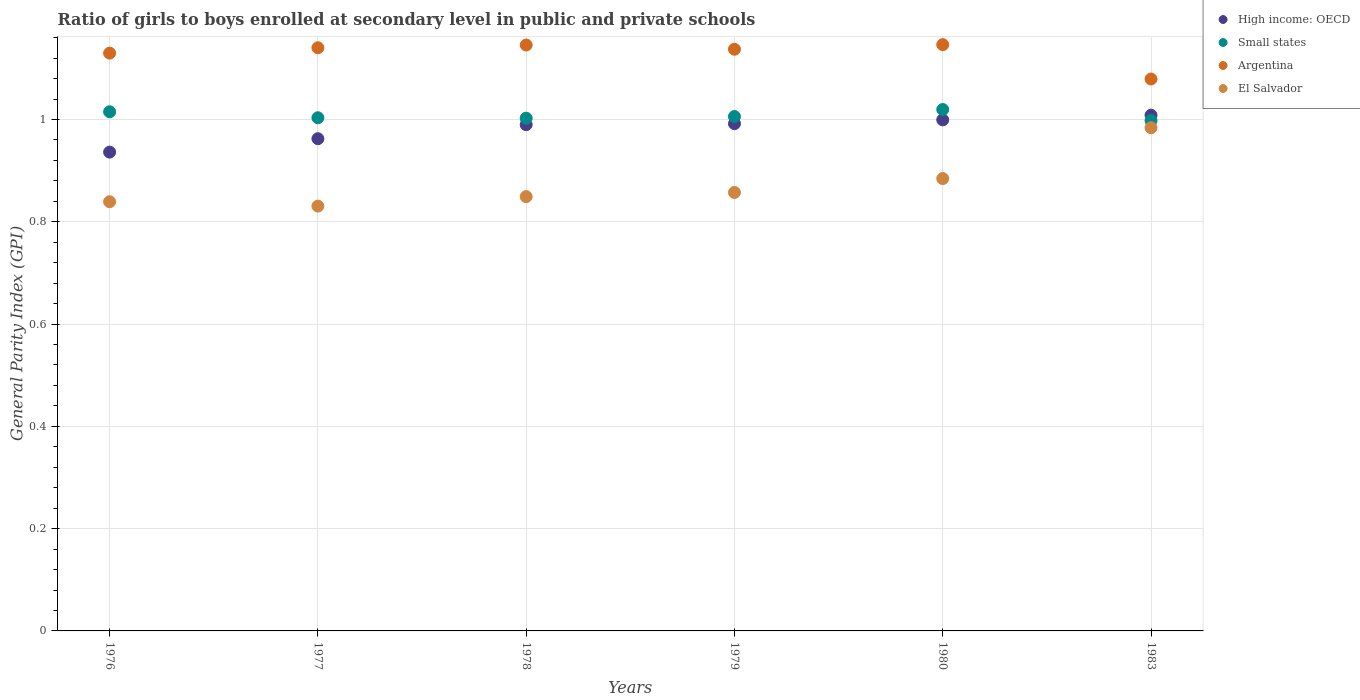Is the number of dotlines equal to the number of legend labels?
Make the answer very short. Yes. What is the general parity index in High income: OECD in 1979?
Provide a short and direct response. 0.99. Across all years, what is the maximum general parity index in El Salvador?
Ensure brevity in your answer.  0.98. Across all years, what is the minimum general parity index in High income: OECD?
Provide a succinct answer. 0.94. What is the total general parity index in Small states in the graph?
Your response must be concise. 6.04. What is the difference between the general parity index in Small states in 1977 and that in 1978?
Make the answer very short. 0. What is the difference between the general parity index in El Salvador in 1976 and the general parity index in High income: OECD in 1977?
Your response must be concise. -0.12. What is the average general parity index in El Salvador per year?
Keep it short and to the point. 0.87. In the year 1977, what is the difference between the general parity index in Argentina and general parity index in Small states?
Provide a succinct answer. 0.14. In how many years, is the general parity index in High income: OECD greater than 0.12?
Your answer should be very brief. 6. What is the ratio of the general parity index in Small states in 1976 to that in 1977?
Provide a short and direct response. 1.01. Is the general parity index in High income: OECD in 1980 less than that in 1983?
Offer a very short reply. Yes. What is the difference between the highest and the second highest general parity index in High income: OECD?
Give a very brief answer. 0.01. What is the difference between the highest and the lowest general parity index in Argentina?
Give a very brief answer. 0.07. In how many years, is the general parity index in Small states greater than the average general parity index in Small states taken over all years?
Make the answer very short. 2. Is the sum of the general parity index in High income: OECD in 1976 and 1983 greater than the maximum general parity index in Argentina across all years?
Offer a terse response. Yes. Is it the case that in every year, the sum of the general parity index in Small states and general parity index in El Salvador  is greater than the sum of general parity index in Argentina and general parity index in High income: OECD?
Provide a short and direct response. No. Is it the case that in every year, the sum of the general parity index in High income: OECD and general parity index in Small states  is greater than the general parity index in Argentina?
Your answer should be very brief. Yes. Does the general parity index in Argentina monotonically increase over the years?
Keep it short and to the point. No. How many dotlines are there?
Keep it short and to the point. 4. How many years are there in the graph?
Your answer should be compact. 6. Are the values on the major ticks of Y-axis written in scientific E-notation?
Ensure brevity in your answer.  No. Does the graph contain any zero values?
Keep it short and to the point. No. Does the graph contain grids?
Provide a succinct answer. Yes. Where does the legend appear in the graph?
Your answer should be very brief. Top right. How are the legend labels stacked?
Offer a very short reply. Vertical. What is the title of the graph?
Provide a short and direct response. Ratio of girls to boys enrolled at secondary level in public and private schools. Does "Euro area" appear as one of the legend labels in the graph?
Your answer should be compact. No. What is the label or title of the Y-axis?
Give a very brief answer. General Parity Index (GPI). What is the General Parity Index (GPI) in High income: OECD in 1976?
Your answer should be compact. 0.94. What is the General Parity Index (GPI) in Small states in 1976?
Provide a short and direct response. 1.02. What is the General Parity Index (GPI) in Argentina in 1976?
Your answer should be very brief. 1.13. What is the General Parity Index (GPI) in El Salvador in 1976?
Provide a succinct answer. 0.84. What is the General Parity Index (GPI) of High income: OECD in 1977?
Ensure brevity in your answer.  0.96. What is the General Parity Index (GPI) in Small states in 1977?
Your answer should be very brief. 1. What is the General Parity Index (GPI) of Argentina in 1977?
Offer a terse response. 1.14. What is the General Parity Index (GPI) of El Salvador in 1977?
Offer a very short reply. 0.83. What is the General Parity Index (GPI) of High income: OECD in 1978?
Provide a short and direct response. 0.99. What is the General Parity Index (GPI) in Small states in 1978?
Provide a succinct answer. 1. What is the General Parity Index (GPI) in Argentina in 1978?
Keep it short and to the point. 1.15. What is the General Parity Index (GPI) of El Salvador in 1978?
Keep it short and to the point. 0.85. What is the General Parity Index (GPI) of High income: OECD in 1979?
Provide a short and direct response. 0.99. What is the General Parity Index (GPI) in Small states in 1979?
Your answer should be compact. 1.01. What is the General Parity Index (GPI) of Argentina in 1979?
Your answer should be very brief. 1.14. What is the General Parity Index (GPI) in El Salvador in 1979?
Offer a terse response. 0.86. What is the General Parity Index (GPI) of High income: OECD in 1980?
Offer a terse response. 1. What is the General Parity Index (GPI) in Small states in 1980?
Provide a short and direct response. 1.02. What is the General Parity Index (GPI) in Argentina in 1980?
Ensure brevity in your answer.  1.15. What is the General Parity Index (GPI) in El Salvador in 1980?
Provide a succinct answer. 0.88. What is the General Parity Index (GPI) in High income: OECD in 1983?
Ensure brevity in your answer.  1.01. What is the General Parity Index (GPI) of Small states in 1983?
Offer a terse response. 1. What is the General Parity Index (GPI) of Argentina in 1983?
Your answer should be very brief. 1.08. What is the General Parity Index (GPI) of El Salvador in 1983?
Ensure brevity in your answer.  0.98. Across all years, what is the maximum General Parity Index (GPI) of High income: OECD?
Your answer should be very brief. 1.01. Across all years, what is the maximum General Parity Index (GPI) in Small states?
Ensure brevity in your answer.  1.02. Across all years, what is the maximum General Parity Index (GPI) of Argentina?
Offer a terse response. 1.15. Across all years, what is the maximum General Parity Index (GPI) of El Salvador?
Keep it short and to the point. 0.98. Across all years, what is the minimum General Parity Index (GPI) of High income: OECD?
Your response must be concise. 0.94. Across all years, what is the minimum General Parity Index (GPI) in Small states?
Ensure brevity in your answer.  1. Across all years, what is the minimum General Parity Index (GPI) in Argentina?
Offer a terse response. 1.08. Across all years, what is the minimum General Parity Index (GPI) of El Salvador?
Make the answer very short. 0.83. What is the total General Parity Index (GPI) in High income: OECD in the graph?
Your answer should be compact. 5.89. What is the total General Parity Index (GPI) of Small states in the graph?
Give a very brief answer. 6.04. What is the total General Parity Index (GPI) of Argentina in the graph?
Offer a very short reply. 6.78. What is the total General Parity Index (GPI) in El Salvador in the graph?
Keep it short and to the point. 5.24. What is the difference between the General Parity Index (GPI) in High income: OECD in 1976 and that in 1977?
Offer a terse response. -0.03. What is the difference between the General Parity Index (GPI) in Small states in 1976 and that in 1977?
Offer a very short reply. 0.01. What is the difference between the General Parity Index (GPI) in Argentina in 1976 and that in 1977?
Provide a succinct answer. -0.01. What is the difference between the General Parity Index (GPI) of El Salvador in 1976 and that in 1977?
Keep it short and to the point. 0.01. What is the difference between the General Parity Index (GPI) in High income: OECD in 1976 and that in 1978?
Keep it short and to the point. -0.05. What is the difference between the General Parity Index (GPI) of Small states in 1976 and that in 1978?
Give a very brief answer. 0.01. What is the difference between the General Parity Index (GPI) of Argentina in 1976 and that in 1978?
Make the answer very short. -0.02. What is the difference between the General Parity Index (GPI) of El Salvador in 1976 and that in 1978?
Your answer should be compact. -0.01. What is the difference between the General Parity Index (GPI) of High income: OECD in 1976 and that in 1979?
Offer a terse response. -0.06. What is the difference between the General Parity Index (GPI) of Small states in 1976 and that in 1979?
Offer a very short reply. 0.01. What is the difference between the General Parity Index (GPI) of Argentina in 1976 and that in 1979?
Your response must be concise. -0.01. What is the difference between the General Parity Index (GPI) of El Salvador in 1976 and that in 1979?
Offer a very short reply. -0.02. What is the difference between the General Parity Index (GPI) in High income: OECD in 1976 and that in 1980?
Your response must be concise. -0.06. What is the difference between the General Parity Index (GPI) of Small states in 1976 and that in 1980?
Offer a terse response. -0. What is the difference between the General Parity Index (GPI) of Argentina in 1976 and that in 1980?
Offer a terse response. -0.02. What is the difference between the General Parity Index (GPI) of El Salvador in 1976 and that in 1980?
Your response must be concise. -0.05. What is the difference between the General Parity Index (GPI) in High income: OECD in 1976 and that in 1983?
Offer a very short reply. -0.07. What is the difference between the General Parity Index (GPI) of Small states in 1976 and that in 1983?
Your answer should be compact. 0.02. What is the difference between the General Parity Index (GPI) in Argentina in 1976 and that in 1983?
Offer a terse response. 0.05. What is the difference between the General Parity Index (GPI) in El Salvador in 1976 and that in 1983?
Provide a short and direct response. -0.14. What is the difference between the General Parity Index (GPI) in High income: OECD in 1977 and that in 1978?
Keep it short and to the point. -0.03. What is the difference between the General Parity Index (GPI) of Small states in 1977 and that in 1978?
Ensure brevity in your answer.  0. What is the difference between the General Parity Index (GPI) in Argentina in 1977 and that in 1978?
Provide a short and direct response. -0.01. What is the difference between the General Parity Index (GPI) in El Salvador in 1977 and that in 1978?
Keep it short and to the point. -0.02. What is the difference between the General Parity Index (GPI) of High income: OECD in 1977 and that in 1979?
Make the answer very short. -0.03. What is the difference between the General Parity Index (GPI) of Small states in 1977 and that in 1979?
Provide a short and direct response. -0. What is the difference between the General Parity Index (GPI) in Argentina in 1977 and that in 1979?
Offer a very short reply. 0. What is the difference between the General Parity Index (GPI) in El Salvador in 1977 and that in 1979?
Give a very brief answer. -0.03. What is the difference between the General Parity Index (GPI) of High income: OECD in 1977 and that in 1980?
Offer a very short reply. -0.04. What is the difference between the General Parity Index (GPI) in Small states in 1977 and that in 1980?
Your answer should be compact. -0.02. What is the difference between the General Parity Index (GPI) of Argentina in 1977 and that in 1980?
Provide a succinct answer. -0.01. What is the difference between the General Parity Index (GPI) in El Salvador in 1977 and that in 1980?
Keep it short and to the point. -0.05. What is the difference between the General Parity Index (GPI) in High income: OECD in 1977 and that in 1983?
Keep it short and to the point. -0.05. What is the difference between the General Parity Index (GPI) of Small states in 1977 and that in 1983?
Give a very brief answer. 0.01. What is the difference between the General Parity Index (GPI) in Argentina in 1977 and that in 1983?
Offer a terse response. 0.06. What is the difference between the General Parity Index (GPI) in El Salvador in 1977 and that in 1983?
Offer a terse response. -0.15. What is the difference between the General Parity Index (GPI) in High income: OECD in 1978 and that in 1979?
Make the answer very short. -0. What is the difference between the General Parity Index (GPI) in Small states in 1978 and that in 1979?
Make the answer very short. -0. What is the difference between the General Parity Index (GPI) in Argentina in 1978 and that in 1979?
Offer a terse response. 0.01. What is the difference between the General Parity Index (GPI) of El Salvador in 1978 and that in 1979?
Give a very brief answer. -0.01. What is the difference between the General Parity Index (GPI) of High income: OECD in 1978 and that in 1980?
Your answer should be very brief. -0.01. What is the difference between the General Parity Index (GPI) of Small states in 1978 and that in 1980?
Give a very brief answer. -0.02. What is the difference between the General Parity Index (GPI) in Argentina in 1978 and that in 1980?
Your response must be concise. -0. What is the difference between the General Parity Index (GPI) in El Salvador in 1978 and that in 1980?
Ensure brevity in your answer.  -0.04. What is the difference between the General Parity Index (GPI) of High income: OECD in 1978 and that in 1983?
Your answer should be compact. -0.02. What is the difference between the General Parity Index (GPI) of Small states in 1978 and that in 1983?
Ensure brevity in your answer.  0. What is the difference between the General Parity Index (GPI) of Argentina in 1978 and that in 1983?
Your answer should be compact. 0.07. What is the difference between the General Parity Index (GPI) in El Salvador in 1978 and that in 1983?
Your response must be concise. -0.13. What is the difference between the General Parity Index (GPI) of High income: OECD in 1979 and that in 1980?
Offer a very short reply. -0.01. What is the difference between the General Parity Index (GPI) in Small states in 1979 and that in 1980?
Your response must be concise. -0.01. What is the difference between the General Parity Index (GPI) of Argentina in 1979 and that in 1980?
Your response must be concise. -0.01. What is the difference between the General Parity Index (GPI) of El Salvador in 1979 and that in 1980?
Give a very brief answer. -0.03. What is the difference between the General Parity Index (GPI) of High income: OECD in 1979 and that in 1983?
Keep it short and to the point. -0.02. What is the difference between the General Parity Index (GPI) of Small states in 1979 and that in 1983?
Give a very brief answer. 0.01. What is the difference between the General Parity Index (GPI) of Argentina in 1979 and that in 1983?
Ensure brevity in your answer.  0.06. What is the difference between the General Parity Index (GPI) of El Salvador in 1979 and that in 1983?
Provide a succinct answer. -0.13. What is the difference between the General Parity Index (GPI) of High income: OECD in 1980 and that in 1983?
Your answer should be compact. -0.01. What is the difference between the General Parity Index (GPI) in Small states in 1980 and that in 1983?
Provide a succinct answer. 0.02. What is the difference between the General Parity Index (GPI) of Argentina in 1980 and that in 1983?
Give a very brief answer. 0.07. What is the difference between the General Parity Index (GPI) in El Salvador in 1980 and that in 1983?
Provide a succinct answer. -0.1. What is the difference between the General Parity Index (GPI) in High income: OECD in 1976 and the General Parity Index (GPI) in Small states in 1977?
Keep it short and to the point. -0.07. What is the difference between the General Parity Index (GPI) of High income: OECD in 1976 and the General Parity Index (GPI) of Argentina in 1977?
Offer a terse response. -0.2. What is the difference between the General Parity Index (GPI) in High income: OECD in 1976 and the General Parity Index (GPI) in El Salvador in 1977?
Offer a very short reply. 0.11. What is the difference between the General Parity Index (GPI) in Small states in 1976 and the General Parity Index (GPI) in Argentina in 1977?
Ensure brevity in your answer.  -0.13. What is the difference between the General Parity Index (GPI) in Small states in 1976 and the General Parity Index (GPI) in El Salvador in 1977?
Make the answer very short. 0.18. What is the difference between the General Parity Index (GPI) in Argentina in 1976 and the General Parity Index (GPI) in El Salvador in 1977?
Provide a succinct answer. 0.3. What is the difference between the General Parity Index (GPI) in High income: OECD in 1976 and the General Parity Index (GPI) in Small states in 1978?
Keep it short and to the point. -0.07. What is the difference between the General Parity Index (GPI) in High income: OECD in 1976 and the General Parity Index (GPI) in Argentina in 1978?
Keep it short and to the point. -0.21. What is the difference between the General Parity Index (GPI) of High income: OECD in 1976 and the General Parity Index (GPI) of El Salvador in 1978?
Keep it short and to the point. 0.09. What is the difference between the General Parity Index (GPI) in Small states in 1976 and the General Parity Index (GPI) in Argentina in 1978?
Provide a short and direct response. -0.13. What is the difference between the General Parity Index (GPI) of Small states in 1976 and the General Parity Index (GPI) of El Salvador in 1978?
Provide a succinct answer. 0.17. What is the difference between the General Parity Index (GPI) of Argentina in 1976 and the General Parity Index (GPI) of El Salvador in 1978?
Provide a short and direct response. 0.28. What is the difference between the General Parity Index (GPI) of High income: OECD in 1976 and the General Parity Index (GPI) of Small states in 1979?
Your answer should be compact. -0.07. What is the difference between the General Parity Index (GPI) of High income: OECD in 1976 and the General Parity Index (GPI) of Argentina in 1979?
Ensure brevity in your answer.  -0.2. What is the difference between the General Parity Index (GPI) of High income: OECD in 1976 and the General Parity Index (GPI) of El Salvador in 1979?
Provide a short and direct response. 0.08. What is the difference between the General Parity Index (GPI) in Small states in 1976 and the General Parity Index (GPI) in Argentina in 1979?
Make the answer very short. -0.12. What is the difference between the General Parity Index (GPI) in Small states in 1976 and the General Parity Index (GPI) in El Salvador in 1979?
Provide a short and direct response. 0.16. What is the difference between the General Parity Index (GPI) of Argentina in 1976 and the General Parity Index (GPI) of El Salvador in 1979?
Give a very brief answer. 0.27. What is the difference between the General Parity Index (GPI) of High income: OECD in 1976 and the General Parity Index (GPI) of Small states in 1980?
Offer a terse response. -0.08. What is the difference between the General Parity Index (GPI) in High income: OECD in 1976 and the General Parity Index (GPI) in Argentina in 1980?
Your response must be concise. -0.21. What is the difference between the General Parity Index (GPI) of High income: OECD in 1976 and the General Parity Index (GPI) of El Salvador in 1980?
Offer a terse response. 0.05. What is the difference between the General Parity Index (GPI) in Small states in 1976 and the General Parity Index (GPI) in Argentina in 1980?
Your answer should be compact. -0.13. What is the difference between the General Parity Index (GPI) of Small states in 1976 and the General Parity Index (GPI) of El Salvador in 1980?
Your answer should be compact. 0.13. What is the difference between the General Parity Index (GPI) of Argentina in 1976 and the General Parity Index (GPI) of El Salvador in 1980?
Keep it short and to the point. 0.25. What is the difference between the General Parity Index (GPI) of High income: OECD in 1976 and the General Parity Index (GPI) of Small states in 1983?
Offer a terse response. -0.06. What is the difference between the General Parity Index (GPI) of High income: OECD in 1976 and the General Parity Index (GPI) of Argentina in 1983?
Your answer should be compact. -0.14. What is the difference between the General Parity Index (GPI) of High income: OECD in 1976 and the General Parity Index (GPI) of El Salvador in 1983?
Provide a short and direct response. -0.05. What is the difference between the General Parity Index (GPI) in Small states in 1976 and the General Parity Index (GPI) in Argentina in 1983?
Provide a succinct answer. -0.06. What is the difference between the General Parity Index (GPI) of Small states in 1976 and the General Parity Index (GPI) of El Salvador in 1983?
Your answer should be compact. 0.03. What is the difference between the General Parity Index (GPI) of Argentina in 1976 and the General Parity Index (GPI) of El Salvador in 1983?
Give a very brief answer. 0.15. What is the difference between the General Parity Index (GPI) in High income: OECD in 1977 and the General Parity Index (GPI) in Small states in 1978?
Ensure brevity in your answer.  -0.04. What is the difference between the General Parity Index (GPI) of High income: OECD in 1977 and the General Parity Index (GPI) of Argentina in 1978?
Your response must be concise. -0.18. What is the difference between the General Parity Index (GPI) in High income: OECD in 1977 and the General Parity Index (GPI) in El Salvador in 1978?
Your answer should be very brief. 0.11. What is the difference between the General Parity Index (GPI) of Small states in 1977 and the General Parity Index (GPI) of Argentina in 1978?
Your answer should be very brief. -0.14. What is the difference between the General Parity Index (GPI) in Small states in 1977 and the General Parity Index (GPI) in El Salvador in 1978?
Ensure brevity in your answer.  0.15. What is the difference between the General Parity Index (GPI) of Argentina in 1977 and the General Parity Index (GPI) of El Salvador in 1978?
Make the answer very short. 0.29. What is the difference between the General Parity Index (GPI) of High income: OECD in 1977 and the General Parity Index (GPI) of Small states in 1979?
Provide a succinct answer. -0.04. What is the difference between the General Parity Index (GPI) in High income: OECD in 1977 and the General Parity Index (GPI) in Argentina in 1979?
Keep it short and to the point. -0.17. What is the difference between the General Parity Index (GPI) of High income: OECD in 1977 and the General Parity Index (GPI) of El Salvador in 1979?
Offer a very short reply. 0.11. What is the difference between the General Parity Index (GPI) in Small states in 1977 and the General Parity Index (GPI) in Argentina in 1979?
Offer a terse response. -0.13. What is the difference between the General Parity Index (GPI) of Small states in 1977 and the General Parity Index (GPI) of El Salvador in 1979?
Provide a succinct answer. 0.15. What is the difference between the General Parity Index (GPI) of Argentina in 1977 and the General Parity Index (GPI) of El Salvador in 1979?
Make the answer very short. 0.28. What is the difference between the General Parity Index (GPI) of High income: OECD in 1977 and the General Parity Index (GPI) of Small states in 1980?
Ensure brevity in your answer.  -0.06. What is the difference between the General Parity Index (GPI) in High income: OECD in 1977 and the General Parity Index (GPI) in Argentina in 1980?
Make the answer very short. -0.18. What is the difference between the General Parity Index (GPI) in High income: OECD in 1977 and the General Parity Index (GPI) in El Salvador in 1980?
Provide a short and direct response. 0.08. What is the difference between the General Parity Index (GPI) in Small states in 1977 and the General Parity Index (GPI) in Argentina in 1980?
Provide a succinct answer. -0.14. What is the difference between the General Parity Index (GPI) of Small states in 1977 and the General Parity Index (GPI) of El Salvador in 1980?
Your response must be concise. 0.12. What is the difference between the General Parity Index (GPI) of Argentina in 1977 and the General Parity Index (GPI) of El Salvador in 1980?
Your answer should be compact. 0.26. What is the difference between the General Parity Index (GPI) of High income: OECD in 1977 and the General Parity Index (GPI) of Small states in 1983?
Your answer should be compact. -0.04. What is the difference between the General Parity Index (GPI) of High income: OECD in 1977 and the General Parity Index (GPI) of Argentina in 1983?
Your answer should be compact. -0.12. What is the difference between the General Parity Index (GPI) of High income: OECD in 1977 and the General Parity Index (GPI) of El Salvador in 1983?
Offer a terse response. -0.02. What is the difference between the General Parity Index (GPI) of Small states in 1977 and the General Parity Index (GPI) of Argentina in 1983?
Offer a terse response. -0.08. What is the difference between the General Parity Index (GPI) in Small states in 1977 and the General Parity Index (GPI) in El Salvador in 1983?
Ensure brevity in your answer.  0.02. What is the difference between the General Parity Index (GPI) in Argentina in 1977 and the General Parity Index (GPI) in El Salvador in 1983?
Provide a short and direct response. 0.16. What is the difference between the General Parity Index (GPI) of High income: OECD in 1978 and the General Parity Index (GPI) of Small states in 1979?
Offer a very short reply. -0.02. What is the difference between the General Parity Index (GPI) in High income: OECD in 1978 and the General Parity Index (GPI) in Argentina in 1979?
Keep it short and to the point. -0.15. What is the difference between the General Parity Index (GPI) of High income: OECD in 1978 and the General Parity Index (GPI) of El Salvador in 1979?
Keep it short and to the point. 0.13. What is the difference between the General Parity Index (GPI) in Small states in 1978 and the General Parity Index (GPI) in Argentina in 1979?
Offer a very short reply. -0.13. What is the difference between the General Parity Index (GPI) of Small states in 1978 and the General Parity Index (GPI) of El Salvador in 1979?
Make the answer very short. 0.15. What is the difference between the General Parity Index (GPI) of Argentina in 1978 and the General Parity Index (GPI) of El Salvador in 1979?
Ensure brevity in your answer.  0.29. What is the difference between the General Parity Index (GPI) in High income: OECD in 1978 and the General Parity Index (GPI) in Small states in 1980?
Offer a terse response. -0.03. What is the difference between the General Parity Index (GPI) in High income: OECD in 1978 and the General Parity Index (GPI) in Argentina in 1980?
Give a very brief answer. -0.16. What is the difference between the General Parity Index (GPI) of High income: OECD in 1978 and the General Parity Index (GPI) of El Salvador in 1980?
Provide a short and direct response. 0.11. What is the difference between the General Parity Index (GPI) in Small states in 1978 and the General Parity Index (GPI) in Argentina in 1980?
Keep it short and to the point. -0.14. What is the difference between the General Parity Index (GPI) in Small states in 1978 and the General Parity Index (GPI) in El Salvador in 1980?
Provide a short and direct response. 0.12. What is the difference between the General Parity Index (GPI) of Argentina in 1978 and the General Parity Index (GPI) of El Salvador in 1980?
Provide a short and direct response. 0.26. What is the difference between the General Parity Index (GPI) of High income: OECD in 1978 and the General Parity Index (GPI) of Small states in 1983?
Provide a short and direct response. -0.01. What is the difference between the General Parity Index (GPI) of High income: OECD in 1978 and the General Parity Index (GPI) of Argentina in 1983?
Offer a terse response. -0.09. What is the difference between the General Parity Index (GPI) in High income: OECD in 1978 and the General Parity Index (GPI) in El Salvador in 1983?
Your response must be concise. 0.01. What is the difference between the General Parity Index (GPI) in Small states in 1978 and the General Parity Index (GPI) in Argentina in 1983?
Give a very brief answer. -0.08. What is the difference between the General Parity Index (GPI) of Small states in 1978 and the General Parity Index (GPI) of El Salvador in 1983?
Make the answer very short. 0.02. What is the difference between the General Parity Index (GPI) in Argentina in 1978 and the General Parity Index (GPI) in El Salvador in 1983?
Make the answer very short. 0.16. What is the difference between the General Parity Index (GPI) of High income: OECD in 1979 and the General Parity Index (GPI) of Small states in 1980?
Provide a succinct answer. -0.03. What is the difference between the General Parity Index (GPI) of High income: OECD in 1979 and the General Parity Index (GPI) of Argentina in 1980?
Offer a very short reply. -0.15. What is the difference between the General Parity Index (GPI) of High income: OECD in 1979 and the General Parity Index (GPI) of El Salvador in 1980?
Give a very brief answer. 0.11. What is the difference between the General Parity Index (GPI) of Small states in 1979 and the General Parity Index (GPI) of Argentina in 1980?
Provide a succinct answer. -0.14. What is the difference between the General Parity Index (GPI) of Small states in 1979 and the General Parity Index (GPI) of El Salvador in 1980?
Your answer should be compact. 0.12. What is the difference between the General Parity Index (GPI) of Argentina in 1979 and the General Parity Index (GPI) of El Salvador in 1980?
Give a very brief answer. 0.25. What is the difference between the General Parity Index (GPI) in High income: OECD in 1979 and the General Parity Index (GPI) in Small states in 1983?
Give a very brief answer. -0.01. What is the difference between the General Parity Index (GPI) of High income: OECD in 1979 and the General Parity Index (GPI) of Argentina in 1983?
Your answer should be very brief. -0.09. What is the difference between the General Parity Index (GPI) in High income: OECD in 1979 and the General Parity Index (GPI) in El Salvador in 1983?
Your answer should be very brief. 0.01. What is the difference between the General Parity Index (GPI) in Small states in 1979 and the General Parity Index (GPI) in Argentina in 1983?
Offer a terse response. -0.07. What is the difference between the General Parity Index (GPI) of Small states in 1979 and the General Parity Index (GPI) of El Salvador in 1983?
Your answer should be very brief. 0.02. What is the difference between the General Parity Index (GPI) in Argentina in 1979 and the General Parity Index (GPI) in El Salvador in 1983?
Your answer should be very brief. 0.15. What is the difference between the General Parity Index (GPI) of High income: OECD in 1980 and the General Parity Index (GPI) of Small states in 1983?
Give a very brief answer. 0. What is the difference between the General Parity Index (GPI) in High income: OECD in 1980 and the General Parity Index (GPI) in Argentina in 1983?
Offer a terse response. -0.08. What is the difference between the General Parity Index (GPI) of High income: OECD in 1980 and the General Parity Index (GPI) of El Salvador in 1983?
Make the answer very short. 0.02. What is the difference between the General Parity Index (GPI) of Small states in 1980 and the General Parity Index (GPI) of Argentina in 1983?
Your answer should be very brief. -0.06. What is the difference between the General Parity Index (GPI) of Small states in 1980 and the General Parity Index (GPI) of El Salvador in 1983?
Provide a short and direct response. 0.04. What is the difference between the General Parity Index (GPI) of Argentina in 1980 and the General Parity Index (GPI) of El Salvador in 1983?
Offer a terse response. 0.16. What is the average General Parity Index (GPI) in High income: OECD per year?
Offer a terse response. 0.98. What is the average General Parity Index (GPI) in Small states per year?
Your response must be concise. 1.01. What is the average General Parity Index (GPI) of Argentina per year?
Offer a very short reply. 1.13. What is the average General Parity Index (GPI) of El Salvador per year?
Provide a short and direct response. 0.87. In the year 1976, what is the difference between the General Parity Index (GPI) in High income: OECD and General Parity Index (GPI) in Small states?
Keep it short and to the point. -0.08. In the year 1976, what is the difference between the General Parity Index (GPI) of High income: OECD and General Parity Index (GPI) of Argentina?
Provide a succinct answer. -0.19. In the year 1976, what is the difference between the General Parity Index (GPI) in High income: OECD and General Parity Index (GPI) in El Salvador?
Your answer should be compact. 0.1. In the year 1976, what is the difference between the General Parity Index (GPI) in Small states and General Parity Index (GPI) in Argentina?
Provide a short and direct response. -0.11. In the year 1976, what is the difference between the General Parity Index (GPI) in Small states and General Parity Index (GPI) in El Salvador?
Give a very brief answer. 0.18. In the year 1976, what is the difference between the General Parity Index (GPI) of Argentina and General Parity Index (GPI) of El Salvador?
Your answer should be compact. 0.29. In the year 1977, what is the difference between the General Parity Index (GPI) of High income: OECD and General Parity Index (GPI) of Small states?
Keep it short and to the point. -0.04. In the year 1977, what is the difference between the General Parity Index (GPI) of High income: OECD and General Parity Index (GPI) of Argentina?
Your answer should be very brief. -0.18. In the year 1977, what is the difference between the General Parity Index (GPI) in High income: OECD and General Parity Index (GPI) in El Salvador?
Provide a short and direct response. 0.13. In the year 1977, what is the difference between the General Parity Index (GPI) in Small states and General Parity Index (GPI) in Argentina?
Your answer should be compact. -0.14. In the year 1977, what is the difference between the General Parity Index (GPI) of Small states and General Parity Index (GPI) of El Salvador?
Your answer should be compact. 0.17. In the year 1977, what is the difference between the General Parity Index (GPI) in Argentina and General Parity Index (GPI) in El Salvador?
Provide a succinct answer. 0.31. In the year 1978, what is the difference between the General Parity Index (GPI) of High income: OECD and General Parity Index (GPI) of Small states?
Offer a terse response. -0.01. In the year 1978, what is the difference between the General Parity Index (GPI) in High income: OECD and General Parity Index (GPI) in Argentina?
Provide a short and direct response. -0.16. In the year 1978, what is the difference between the General Parity Index (GPI) in High income: OECD and General Parity Index (GPI) in El Salvador?
Offer a very short reply. 0.14. In the year 1978, what is the difference between the General Parity Index (GPI) in Small states and General Parity Index (GPI) in Argentina?
Provide a succinct answer. -0.14. In the year 1978, what is the difference between the General Parity Index (GPI) of Small states and General Parity Index (GPI) of El Salvador?
Keep it short and to the point. 0.15. In the year 1978, what is the difference between the General Parity Index (GPI) in Argentina and General Parity Index (GPI) in El Salvador?
Give a very brief answer. 0.3. In the year 1979, what is the difference between the General Parity Index (GPI) in High income: OECD and General Parity Index (GPI) in Small states?
Provide a succinct answer. -0.01. In the year 1979, what is the difference between the General Parity Index (GPI) of High income: OECD and General Parity Index (GPI) of Argentina?
Offer a terse response. -0.15. In the year 1979, what is the difference between the General Parity Index (GPI) of High income: OECD and General Parity Index (GPI) of El Salvador?
Give a very brief answer. 0.13. In the year 1979, what is the difference between the General Parity Index (GPI) of Small states and General Parity Index (GPI) of Argentina?
Your response must be concise. -0.13. In the year 1979, what is the difference between the General Parity Index (GPI) in Small states and General Parity Index (GPI) in El Salvador?
Provide a succinct answer. 0.15. In the year 1979, what is the difference between the General Parity Index (GPI) in Argentina and General Parity Index (GPI) in El Salvador?
Your response must be concise. 0.28. In the year 1980, what is the difference between the General Parity Index (GPI) of High income: OECD and General Parity Index (GPI) of Small states?
Give a very brief answer. -0.02. In the year 1980, what is the difference between the General Parity Index (GPI) in High income: OECD and General Parity Index (GPI) in Argentina?
Your answer should be compact. -0.15. In the year 1980, what is the difference between the General Parity Index (GPI) in High income: OECD and General Parity Index (GPI) in El Salvador?
Your answer should be compact. 0.11. In the year 1980, what is the difference between the General Parity Index (GPI) of Small states and General Parity Index (GPI) of Argentina?
Give a very brief answer. -0.13. In the year 1980, what is the difference between the General Parity Index (GPI) in Small states and General Parity Index (GPI) in El Salvador?
Offer a very short reply. 0.14. In the year 1980, what is the difference between the General Parity Index (GPI) of Argentina and General Parity Index (GPI) of El Salvador?
Make the answer very short. 0.26. In the year 1983, what is the difference between the General Parity Index (GPI) of High income: OECD and General Parity Index (GPI) of Small states?
Give a very brief answer. 0.01. In the year 1983, what is the difference between the General Parity Index (GPI) in High income: OECD and General Parity Index (GPI) in Argentina?
Keep it short and to the point. -0.07. In the year 1983, what is the difference between the General Parity Index (GPI) in High income: OECD and General Parity Index (GPI) in El Salvador?
Offer a terse response. 0.02. In the year 1983, what is the difference between the General Parity Index (GPI) in Small states and General Parity Index (GPI) in Argentina?
Provide a short and direct response. -0.08. In the year 1983, what is the difference between the General Parity Index (GPI) of Small states and General Parity Index (GPI) of El Salvador?
Provide a short and direct response. 0.01. In the year 1983, what is the difference between the General Parity Index (GPI) of Argentina and General Parity Index (GPI) of El Salvador?
Provide a short and direct response. 0.1. What is the ratio of the General Parity Index (GPI) of High income: OECD in 1976 to that in 1977?
Your answer should be compact. 0.97. What is the ratio of the General Parity Index (GPI) in Small states in 1976 to that in 1977?
Ensure brevity in your answer.  1.01. What is the ratio of the General Parity Index (GPI) of El Salvador in 1976 to that in 1977?
Provide a succinct answer. 1.01. What is the ratio of the General Parity Index (GPI) of High income: OECD in 1976 to that in 1978?
Offer a terse response. 0.95. What is the ratio of the General Parity Index (GPI) of Small states in 1976 to that in 1978?
Offer a terse response. 1.01. What is the ratio of the General Parity Index (GPI) in Argentina in 1976 to that in 1978?
Give a very brief answer. 0.99. What is the ratio of the General Parity Index (GPI) in El Salvador in 1976 to that in 1978?
Give a very brief answer. 0.99. What is the ratio of the General Parity Index (GPI) of High income: OECD in 1976 to that in 1979?
Your answer should be compact. 0.94. What is the ratio of the General Parity Index (GPI) of Small states in 1976 to that in 1979?
Provide a short and direct response. 1.01. What is the ratio of the General Parity Index (GPI) in El Salvador in 1976 to that in 1979?
Ensure brevity in your answer.  0.98. What is the ratio of the General Parity Index (GPI) of High income: OECD in 1976 to that in 1980?
Provide a succinct answer. 0.94. What is the ratio of the General Parity Index (GPI) in Small states in 1976 to that in 1980?
Your response must be concise. 1. What is the ratio of the General Parity Index (GPI) of Argentina in 1976 to that in 1980?
Your answer should be compact. 0.99. What is the ratio of the General Parity Index (GPI) of El Salvador in 1976 to that in 1980?
Give a very brief answer. 0.95. What is the ratio of the General Parity Index (GPI) of High income: OECD in 1976 to that in 1983?
Your answer should be very brief. 0.93. What is the ratio of the General Parity Index (GPI) of Small states in 1976 to that in 1983?
Offer a terse response. 1.02. What is the ratio of the General Parity Index (GPI) of Argentina in 1976 to that in 1983?
Your response must be concise. 1.05. What is the ratio of the General Parity Index (GPI) of El Salvador in 1976 to that in 1983?
Your answer should be compact. 0.85. What is the ratio of the General Parity Index (GPI) in High income: OECD in 1977 to that in 1978?
Your answer should be very brief. 0.97. What is the ratio of the General Parity Index (GPI) in Argentina in 1977 to that in 1978?
Your answer should be very brief. 1. What is the ratio of the General Parity Index (GPI) of El Salvador in 1977 to that in 1978?
Your answer should be compact. 0.98. What is the ratio of the General Parity Index (GPI) in High income: OECD in 1977 to that in 1979?
Provide a short and direct response. 0.97. What is the ratio of the General Parity Index (GPI) of El Salvador in 1977 to that in 1979?
Your answer should be compact. 0.97. What is the ratio of the General Parity Index (GPI) in High income: OECD in 1977 to that in 1980?
Offer a very short reply. 0.96. What is the ratio of the General Parity Index (GPI) of Small states in 1977 to that in 1980?
Ensure brevity in your answer.  0.98. What is the ratio of the General Parity Index (GPI) of El Salvador in 1977 to that in 1980?
Ensure brevity in your answer.  0.94. What is the ratio of the General Parity Index (GPI) of High income: OECD in 1977 to that in 1983?
Offer a very short reply. 0.95. What is the ratio of the General Parity Index (GPI) of Argentina in 1977 to that in 1983?
Provide a short and direct response. 1.06. What is the ratio of the General Parity Index (GPI) of El Salvador in 1977 to that in 1983?
Keep it short and to the point. 0.84. What is the ratio of the General Parity Index (GPI) in El Salvador in 1978 to that in 1979?
Provide a succinct answer. 0.99. What is the ratio of the General Parity Index (GPI) in High income: OECD in 1978 to that in 1980?
Your answer should be compact. 0.99. What is the ratio of the General Parity Index (GPI) in Small states in 1978 to that in 1980?
Provide a succinct answer. 0.98. What is the ratio of the General Parity Index (GPI) in El Salvador in 1978 to that in 1980?
Provide a short and direct response. 0.96. What is the ratio of the General Parity Index (GPI) of High income: OECD in 1978 to that in 1983?
Provide a succinct answer. 0.98. What is the ratio of the General Parity Index (GPI) in Argentina in 1978 to that in 1983?
Provide a succinct answer. 1.06. What is the ratio of the General Parity Index (GPI) of El Salvador in 1978 to that in 1983?
Offer a very short reply. 0.86. What is the ratio of the General Parity Index (GPI) in High income: OECD in 1979 to that in 1980?
Your answer should be very brief. 0.99. What is the ratio of the General Parity Index (GPI) of Small states in 1979 to that in 1980?
Your answer should be very brief. 0.99. What is the ratio of the General Parity Index (GPI) of El Salvador in 1979 to that in 1980?
Offer a terse response. 0.97. What is the ratio of the General Parity Index (GPI) of High income: OECD in 1979 to that in 1983?
Offer a very short reply. 0.98. What is the ratio of the General Parity Index (GPI) of Argentina in 1979 to that in 1983?
Offer a terse response. 1.05. What is the ratio of the General Parity Index (GPI) of El Salvador in 1979 to that in 1983?
Your response must be concise. 0.87. What is the ratio of the General Parity Index (GPI) of High income: OECD in 1980 to that in 1983?
Offer a very short reply. 0.99. What is the ratio of the General Parity Index (GPI) in Small states in 1980 to that in 1983?
Offer a terse response. 1.02. What is the ratio of the General Parity Index (GPI) in Argentina in 1980 to that in 1983?
Provide a succinct answer. 1.06. What is the ratio of the General Parity Index (GPI) in El Salvador in 1980 to that in 1983?
Offer a terse response. 0.9. What is the difference between the highest and the second highest General Parity Index (GPI) of High income: OECD?
Your answer should be very brief. 0.01. What is the difference between the highest and the second highest General Parity Index (GPI) in Small states?
Offer a very short reply. 0. What is the difference between the highest and the second highest General Parity Index (GPI) of Argentina?
Provide a short and direct response. 0. What is the difference between the highest and the second highest General Parity Index (GPI) of El Salvador?
Offer a terse response. 0.1. What is the difference between the highest and the lowest General Parity Index (GPI) in High income: OECD?
Provide a short and direct response. 0.07. What is the difference between the highest and the lowest General Parity Index (GPI) in Small states?
Give a very brief answer. 0.02. What is the difference between the highest and the lowest General Parity Index (GPI) in Argentina?
Give a very brief answer. 0.07. What is the difference between the highest and the lowest General Parity Index (GPI) of El Salvador?
Keep it short and to the point. 0.15. 